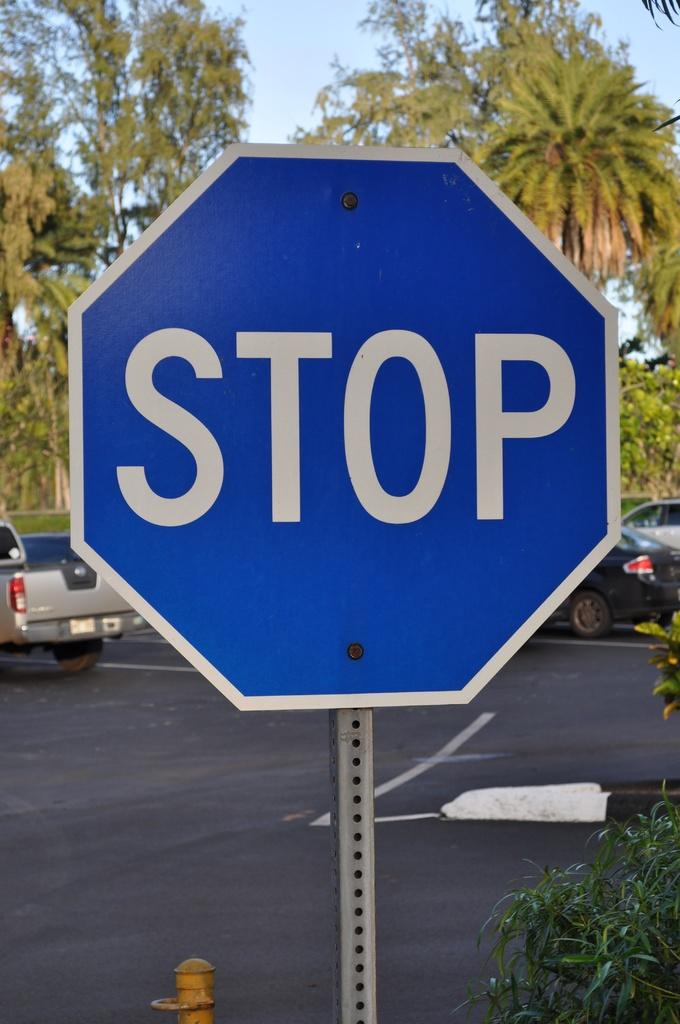<image>
Give a short and clear explanation of the subsequent image. a blue and white sign that says stop in the middle in white lettering. 